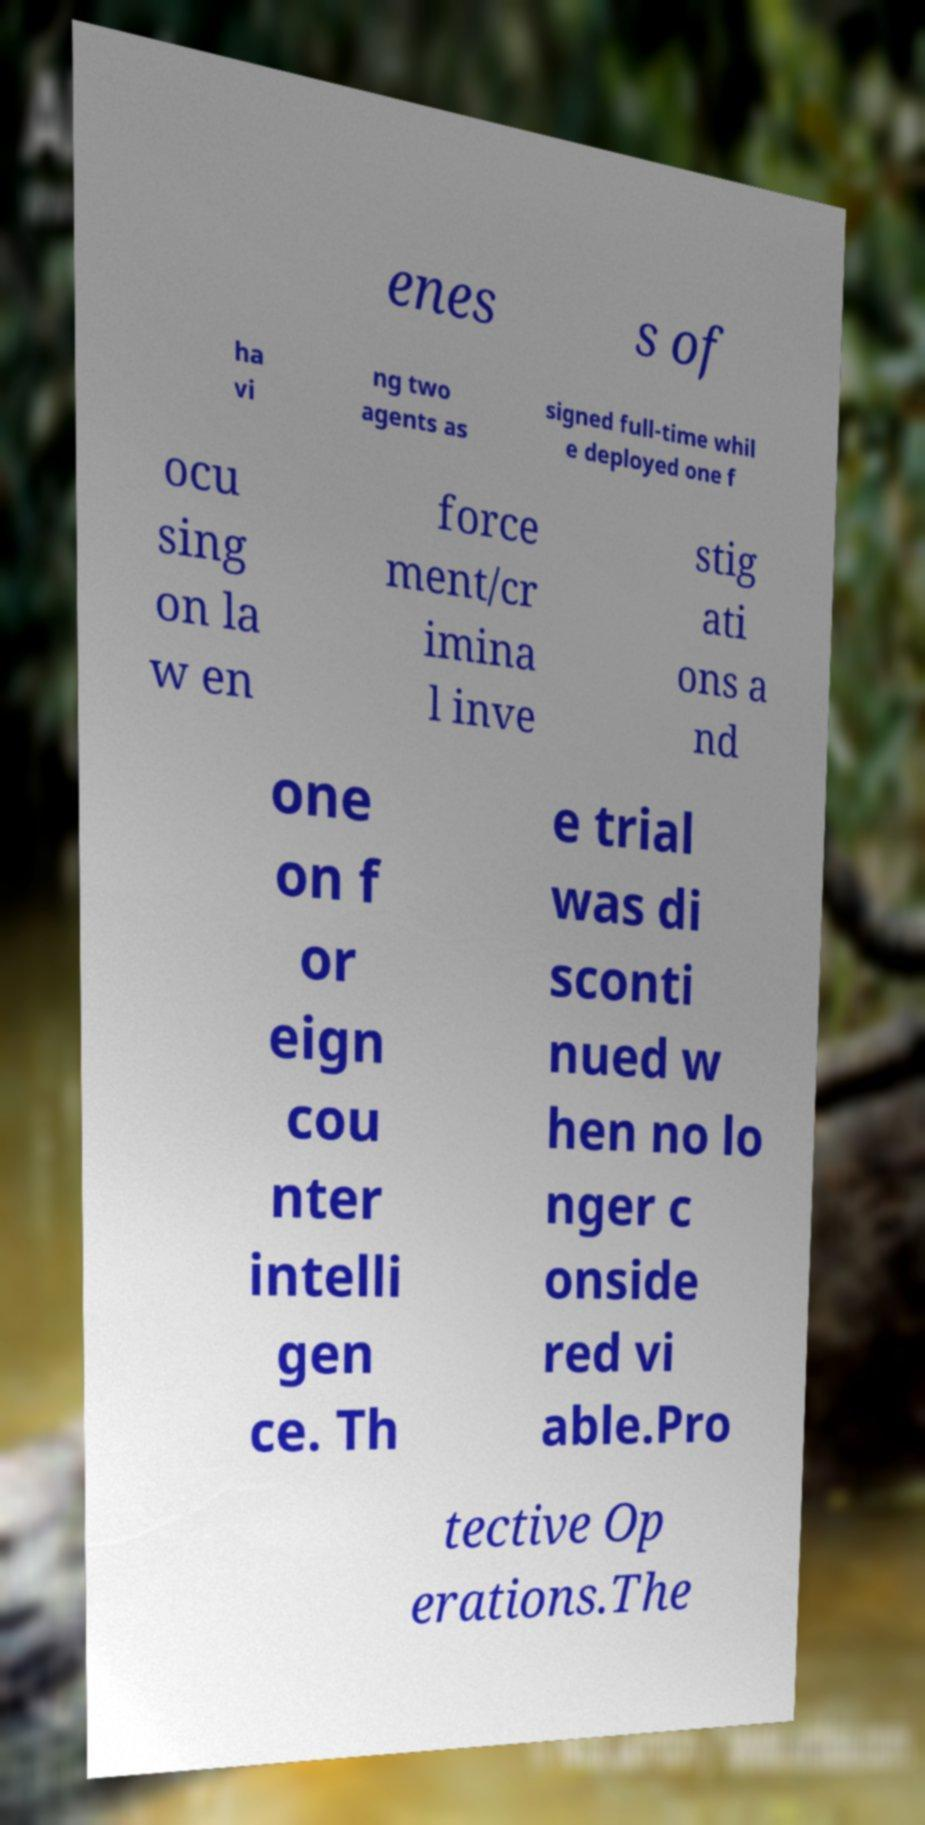Please identify and transcribe the text found in this image. enes s of ha vi ng two agents as signed full-time whil e deployed one f ocu sing on la w en force ment/cr imina l inve stig ati ons a nd one on f or eign cou nter intelli gen ce. Th e trial was di sconti nued w hen no lo nger c onside red vi able.Pro tective Op erations.The 